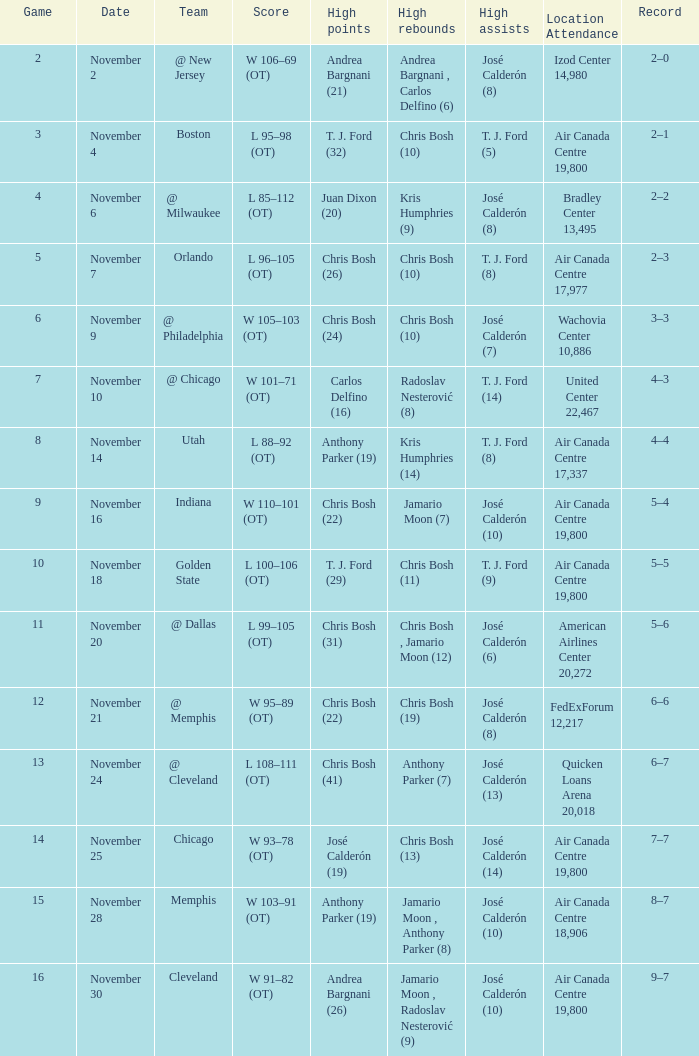What is the score when the team is @ cleveland? L 108–111 (OT). 